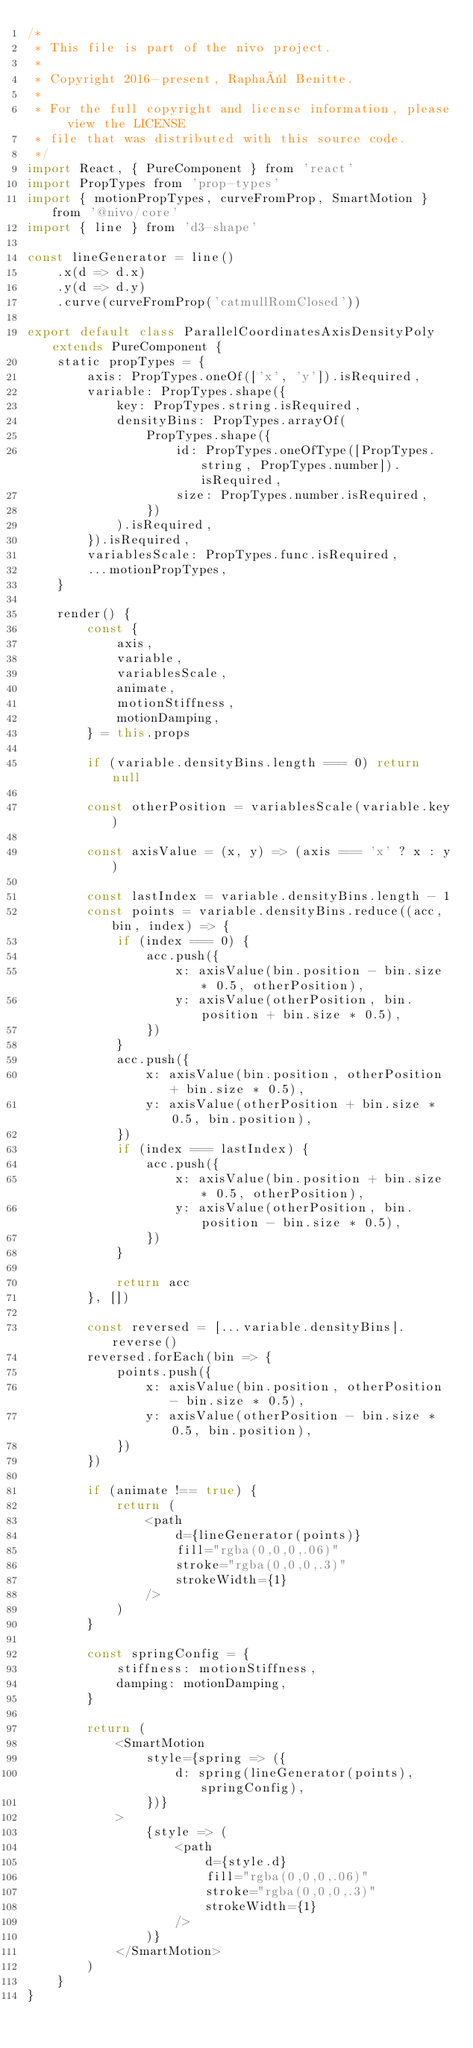Convert code to text. <code><loc_0><loc_0><loc_500><loc_500><_JavaScript_>/*
 * This file is part of the nivo project.
 *
 * Copyright 2016-present, Raphaël Benitte.
 *
 * For the full copyright and license information, please view the LICENSE
 * file that was distributed with this source code.
 */
import React, { PureComponent } from 'react'
import PropTypes from 'prop-types'
import { motionPropTypes, curveFromProp, SmartMotion } from '@nivo/core'
import { line } from 'd3-shape'

const lineGenerator = line()
    .x(d => d.x)
    .y(d => d.y)
    .curve(curveFromProp('catmullRomClosed'))

export default class ParallelCoordinatesAxisDensityPoly extends PureComponent {
    static propTypes = {
        axis: PropTypes.oneOf(['x', 'y']).isRequired,
        variable: PropTypes.shape({
            key: PropTypes.string.isRequired,
            densityBins: PropTypes.arrayOf(
                PropTypes.shape({
                    id: PropTypes.oneOfType([PropTypes.string, PropTypes.number]).isRequired,
                    size: PropTypes.number.isRequired,
                })
            ).isRequired,
        }).isRequired,
        variablesScale: PropTypes.func.isRequired,
        ...motionPropTypes,
    }

    render() {
        const {
            axis,
            variable,
            variablesScale,
            animate,
            motionStiffness,
            motionDamping,
        } = this.props

        if (variable.densityBins.length === 0) return null

        const otherPosition = variablesScale(variable.key)

        const axisValue = (x, y) => (axis === 'x' ? x : y)

        const lastIndex = variable.densityBins.length - 1
        const points = variable.densityBins.reduce((acc, bin, index) => {
            if (index === 0) {
                acc.push({
                    x: axisValue(bin.position - bin.size * 0.5, otherPosition),
                    y: axisValue(otherPosition, bin.position + bin.size * 0.5),
                })
            }
            acc.push({
                x: axisValue(bin.position, otherPosition + bin.size * 0.5),
                y: axisValue(otherPosition + bin.size * 0.5, bin.position),
            })
            if (index === lastIndex) {
                acc.push({
                    x: axisValue(bin.position + bin.size * 0.5, otherPosition),
                    y: axisValue(otherPosition, bin.position - bin.size * 0.5),
                })
            }

            return acc
        }, [])

        const reversed = [...variable.densityBins].reverse()
        reversed.forEach(bin => {
            points.push({
                x: axisValue(bin.position, otherPosition - bin.size * 0.5),
                y: axisValue(otherPosition - bin.size * 0.5, bin.position),
            })
        })

        if (animate !== true) {
            return (
                <path
                    d={lineGenerator(points)}
                    fill="rgba(0,0,0,.06)"
                    stroke="rgba(0,0,0,.3)"
                    strokeWidth={1}
                />
            )
        }

        const springConfig = {
            stiffness: motionStiffness,
            damping: motionDamping,
        }

        return (
            <SmartMotion
                style={spring => ({
                    d: spring(lineGenerator(points), springConfig),
                })}
            >
                {style => (
                    <path
                        d={style.d}
                        fill="rgba(0,0,0,.06)"
                        stroke="rgba(0,0,0,.3)"
                        strokeWidth={1}
                    />
                )}
            </SmartMotion>
        )
    }
}
</code> 